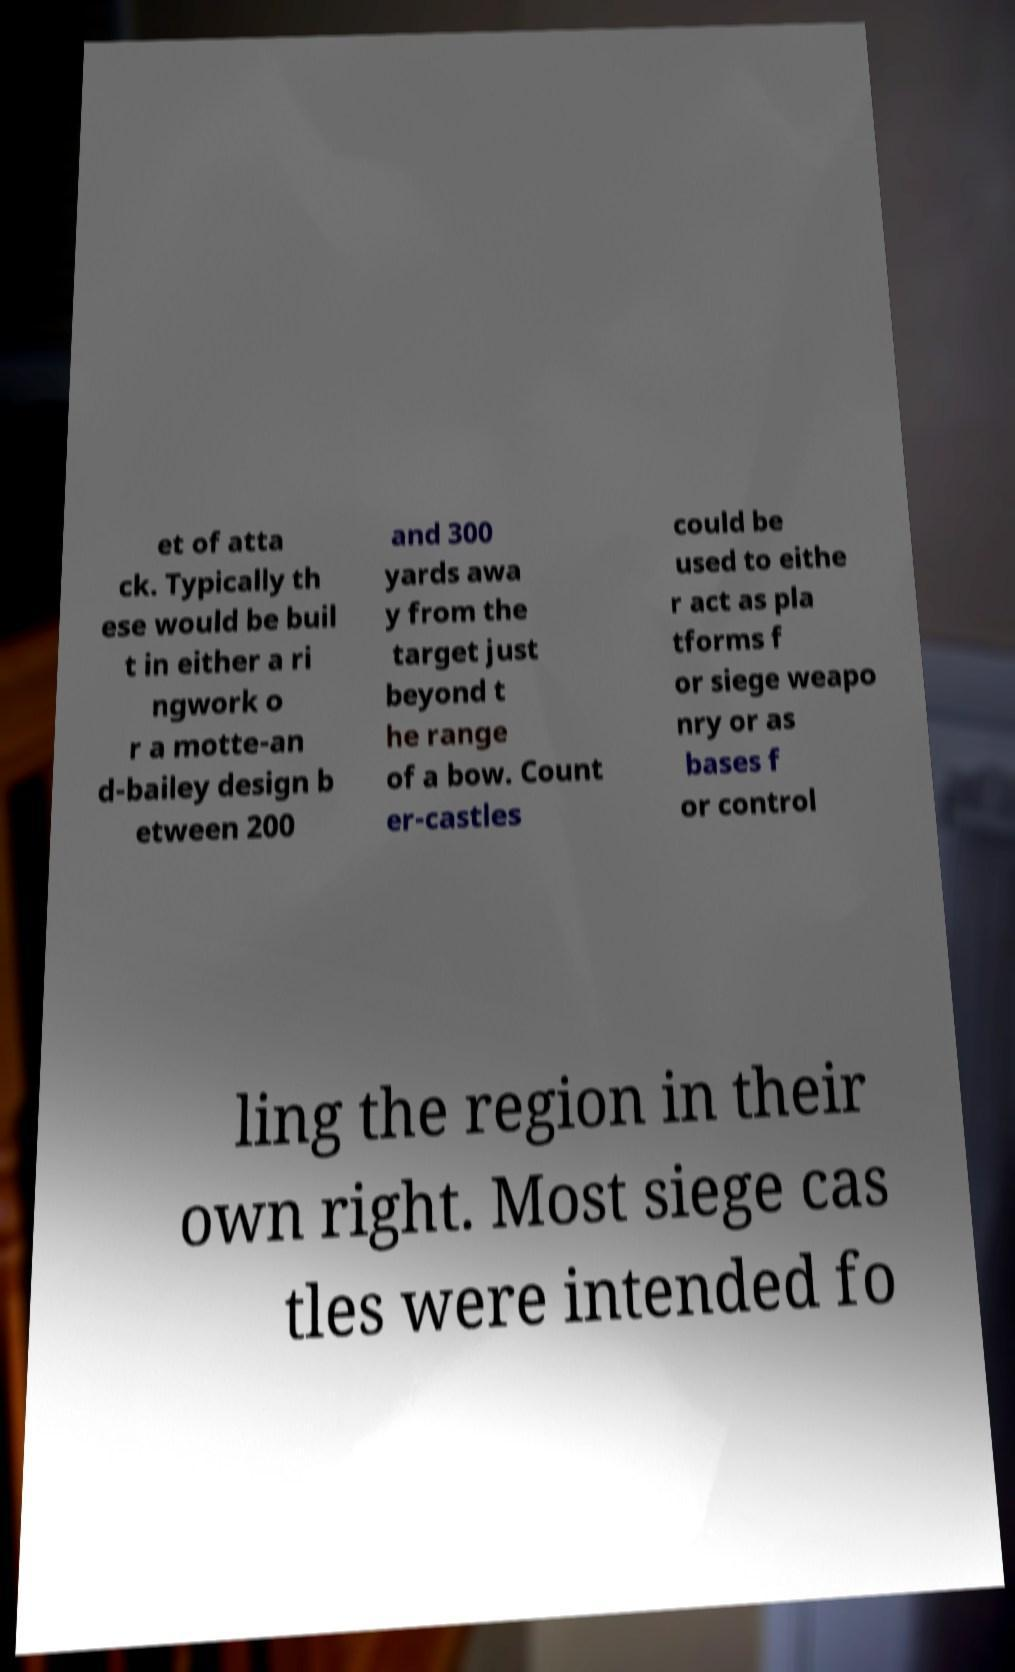Can you read and provide the text displayed in the image?This photo seems to have some interesting text. Can you extract and type it out for me? et of atta ck. Typically th ese would be buil t in either a ri ngwork o r a motte-an d-bailey design b etween 200 and 300 yards awa y from the target just beyond t he range of a bow. Count er-castles could be used to eithe r act as pla tforms f or siege weapo nry or as bases f or control ling the region in their own right. Most siege cas tles were intended fo 